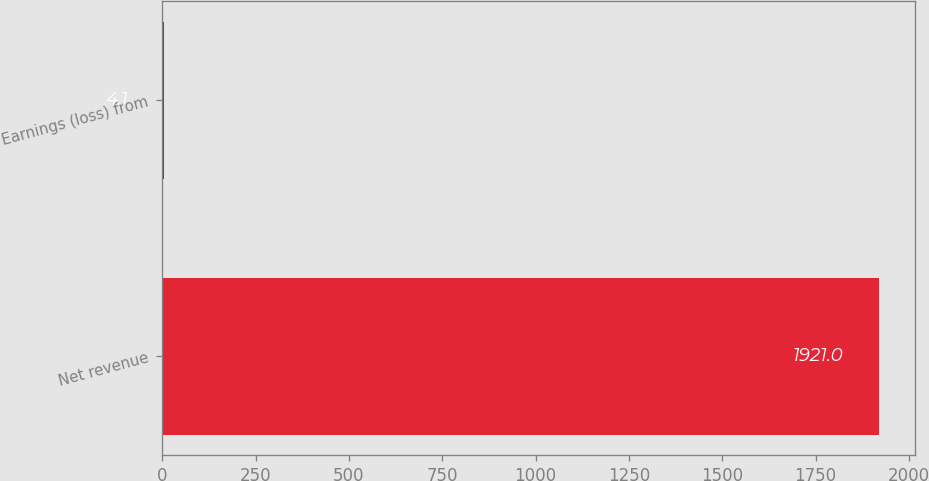Convert chart to OTSL. <chart><loc_0><loc_0><loc_500><loc_500><bar_chart><fcel>Net revenue<fcel>Earnings (loss) from<nl><fcel>1921<fcel>4.1<nl></chart> 